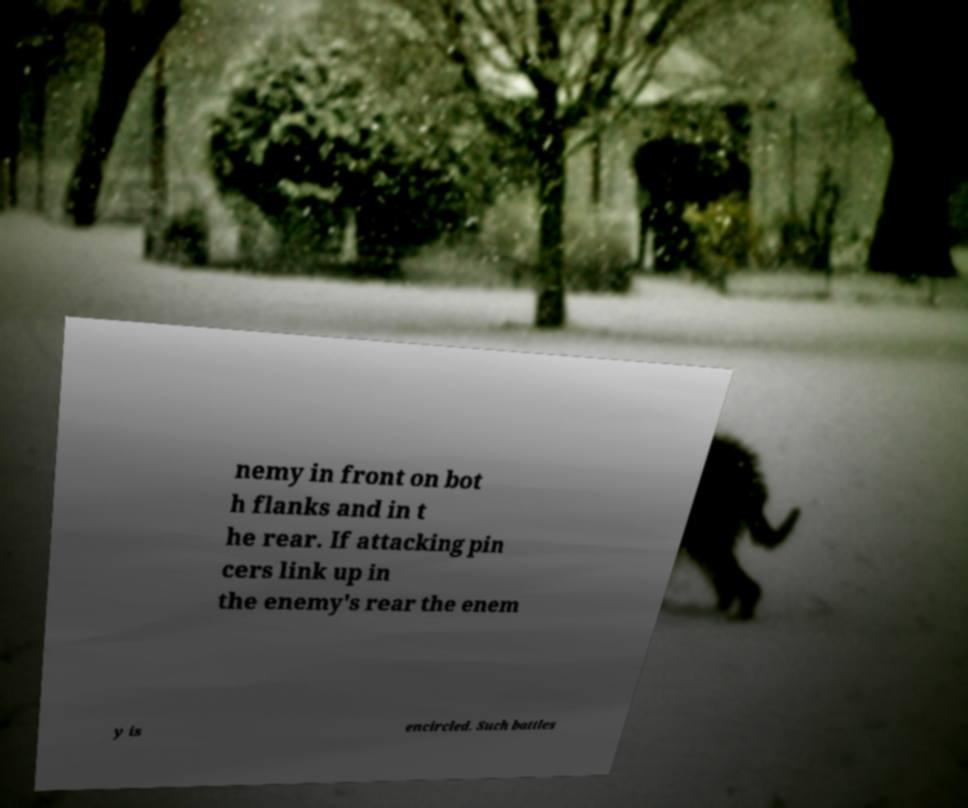Can you read and provide the text displayed in the image?This photo seems to have some interesting text. Can you extract and type it out for me? nemy in front on bot h flanks and in t he rear. If attacking pin cers link up in the enemy's rear the enem y is encircled. Such battles 